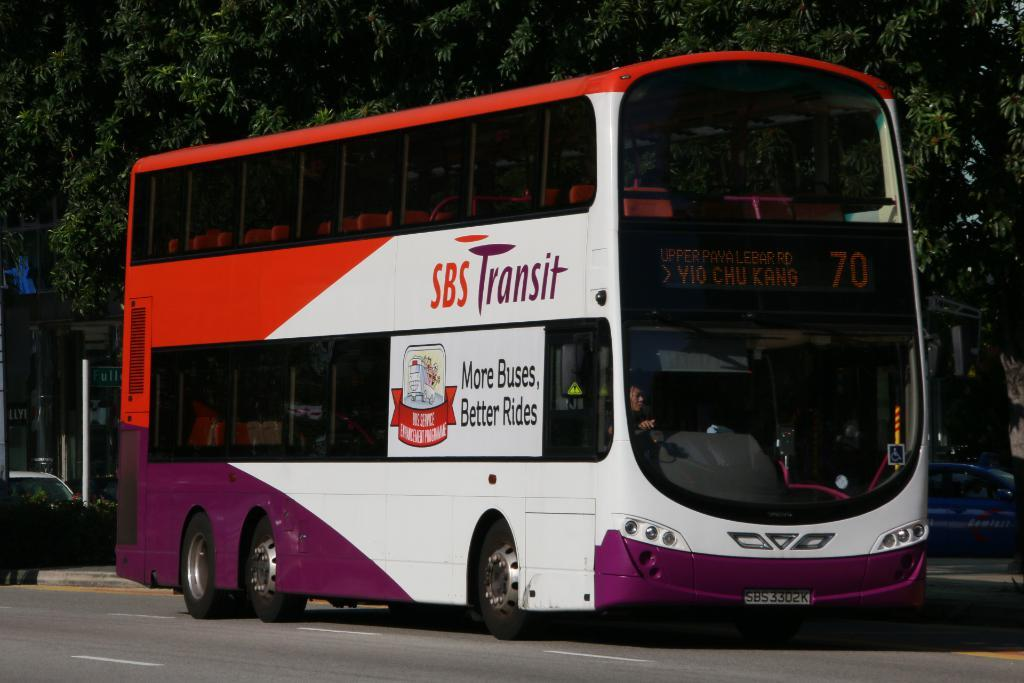What is the main subject in the center of the image? There is a bus in the center of the image. Can you describe the interior of the bus? A person is inside the bus. What can be seen in the background of the image? There are trees in the background of the image. What other vehicle is visible in the image? There is another vehicle on the right side of the image. Where is the quiver located in the image? There is no quiver present in the image. What type of play is being performed in the image? There is no play being performed in the image; it features a bus and a person inside it. 